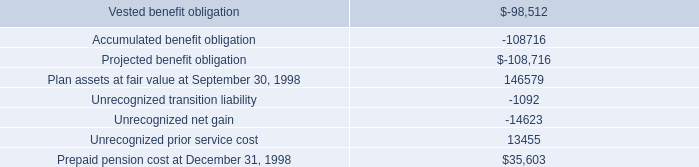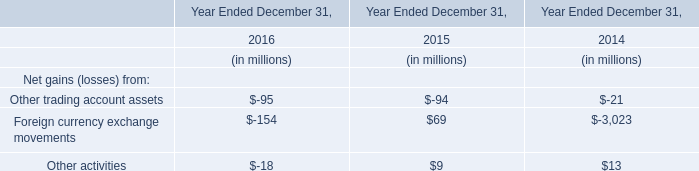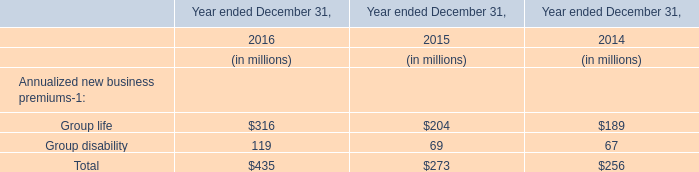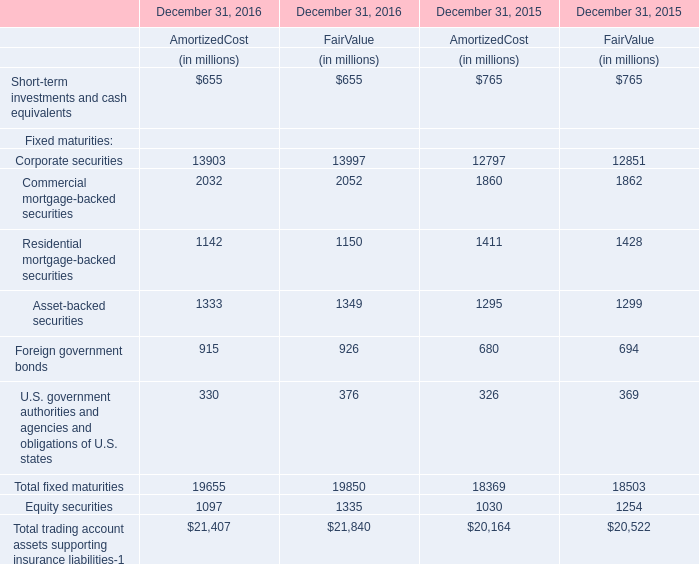What's the 10% of total Fixed maturities for fair value in 2016? (in million) 
Computations: (19850 * 0.1)
Answer: 1985.0. 